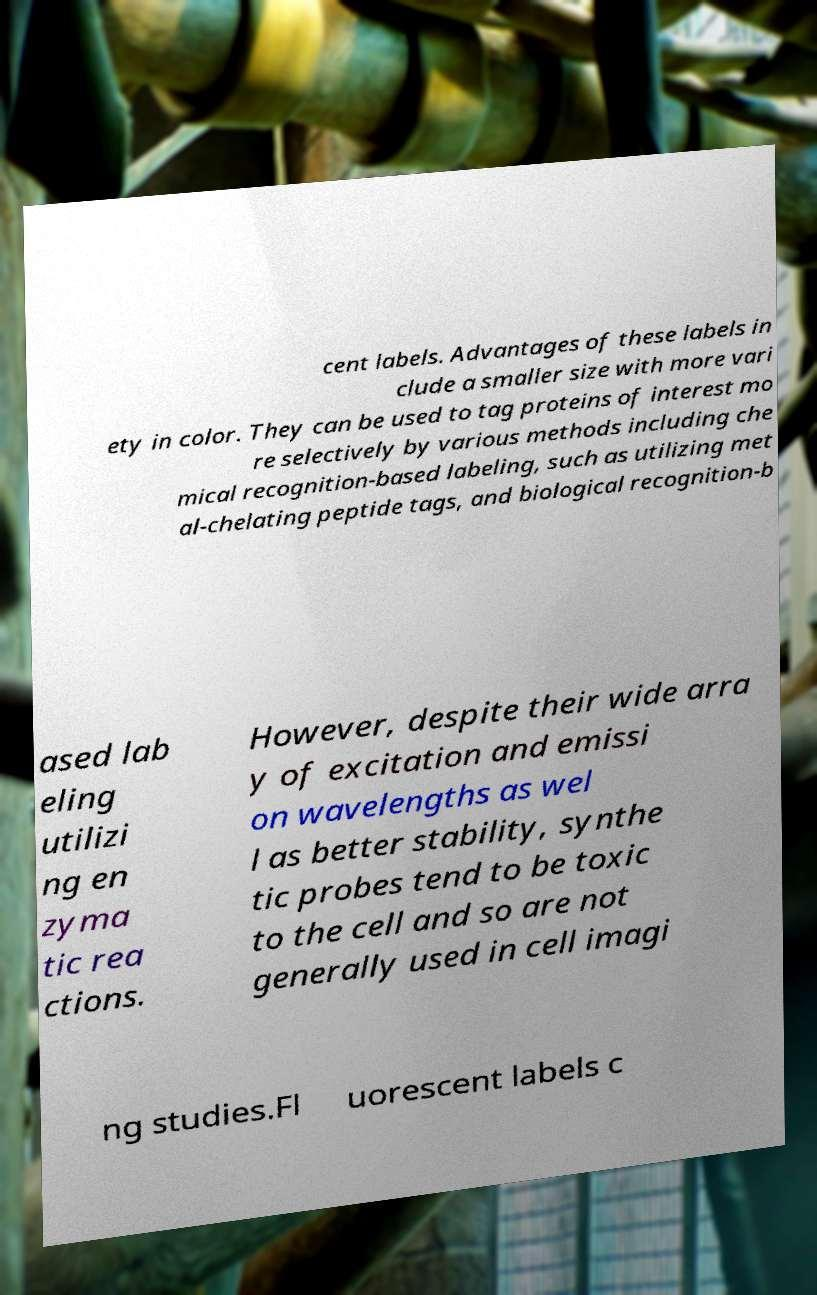Can you accurately transcribe the text from the provided image for me? cent labels. Advantages of these labels in clude a smaller size with more vari ety in color. They can be used to tag proteins of interest mo re selectively by various methods including che mical recognition-based labeling, such as utilizing met al-chelating peptide tags, and biological recognition-b ased lab eling utilizi ng en zyma tic rea ctions. However, despite their wide arra y of excitation and emissi on wavelengths as wel l as better stability, synthe tic probes tend to be toxic to the cell and so are not generally used in cell imagi ng studies.Fl uorescent labels c 